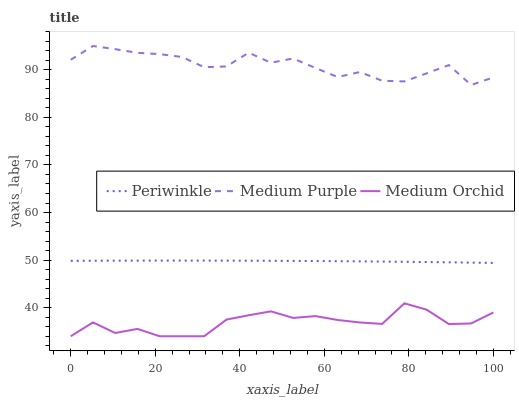Does Periwinkle have the minimum area under the curve?
Answer yes or no. No. Does Periwinkle have the maximum area under the curve?
Answer yes or no. No. Is Medium Orchid the smoothest?
Answer yes or no. No. Is Medium Orchid the roughest?
Answer yes or no. No. Does Periwinkle have the lowest value?
Answer yes or no. No. Does Periwinkle have the highest value?
Answer yes or no. No. Is Periwinkle less than Medium Purple?
Answer yes or no. Yes. Is Medium Purple greater than Periwinkle?
Answer yes or no. Yes. Does Periwinkle intersect Medium Purple?
Answer yes or no. No. 